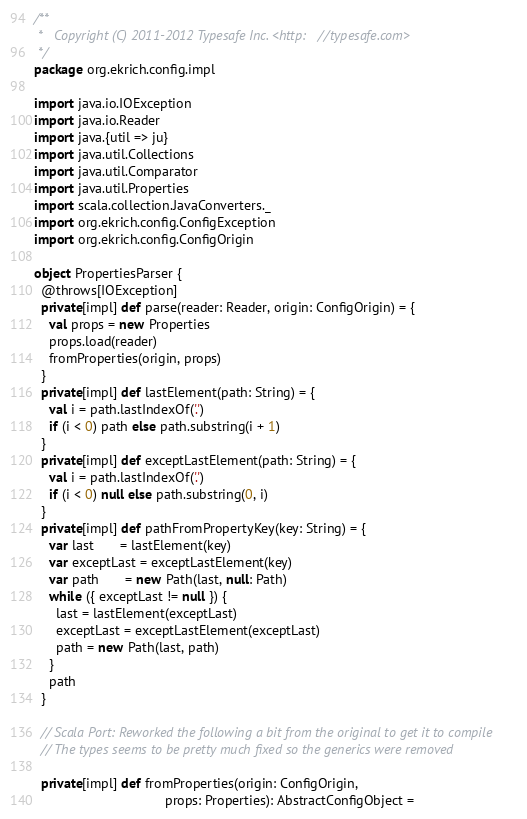Convert code to text. <code><loc_0><loc_0><loc_500><loc_500><_Scala_>/**
 *   Copyright (C) 2011-2012 Typesafe Inc. <http://typesafe.com>
 */
package org.ekrich.config.impl

import java.io.IOException
import java.io.Reader
import java.{util => ju}
import java.util.Collections
import java.util.Comparator
import java.util.Properties
import scala.collection.JavaConverters._
import org.ekrich.config.ConfigException
import org.ekrich.config.ConfigOrigin

object PropertiesParser {
  @throws[IOException]
  private[impl] def parse(reader: Reader, origin: ConfigOrigin) = {
    val props = new Properties
    props.load(reader)
    fromProperties(origin, props)
  }
  private[impl] def lastElement(path: String) = {
    val i = path.lastIndexOf('.')
    if (i < 0) path else path.substring(i + 1)
  }
  private[impl] def exceptLastElement(path: String) = {
    val i = path.lastIndexOf('.')
    if (i < 0) null else path.substring(0, i)
  }
  private[impl] def pathFromPropertyKey(key: String) = {
    var last       = lastElement(key)
    var exceptLast = exceptLastElement(key)
    var path       = new Path(last, null: Path)
    while ({ exceptLast != null }) {
      last = lastElement(exceptLast)
      exceptLast = exceptLastElement(exceptLast)
      path = new Path(last, path)
    }
    path
  }

  // Scala Port: Reworked the following a bit from the original to get it to compile
  // The types seems to be pretty much fixed so the generics were removed

  private[impl] def fromProperties(origin: ConfigOrigin,
                                   props: Properties): AbstractConfigObject =</code> 